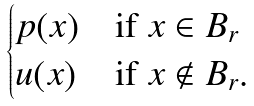<formula> <loc_0><loc_0><loc_500><loc_500>\begin{cases} p ( x ) & \text {if } x \in B _ { r } \\ u ( x ) & \text {if } x \notin B _ { r } . \end{cases}</formula> 